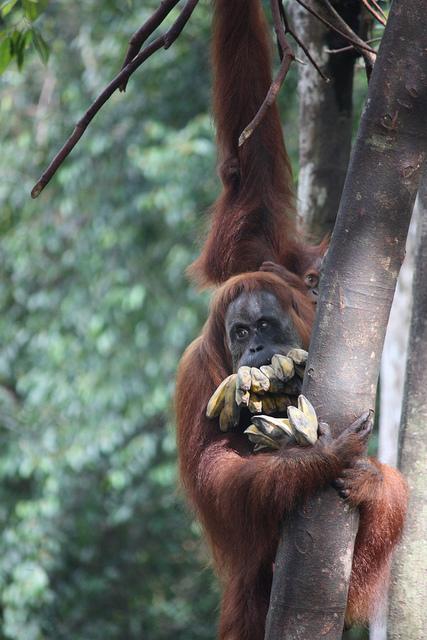What kind of ape is this?
Quick response, please. Orangutan. What will the animal do with the yellow fruit?
Write a very short answer. Eat. What is the ape hanging on to?
Write a very short answer. Tree. 